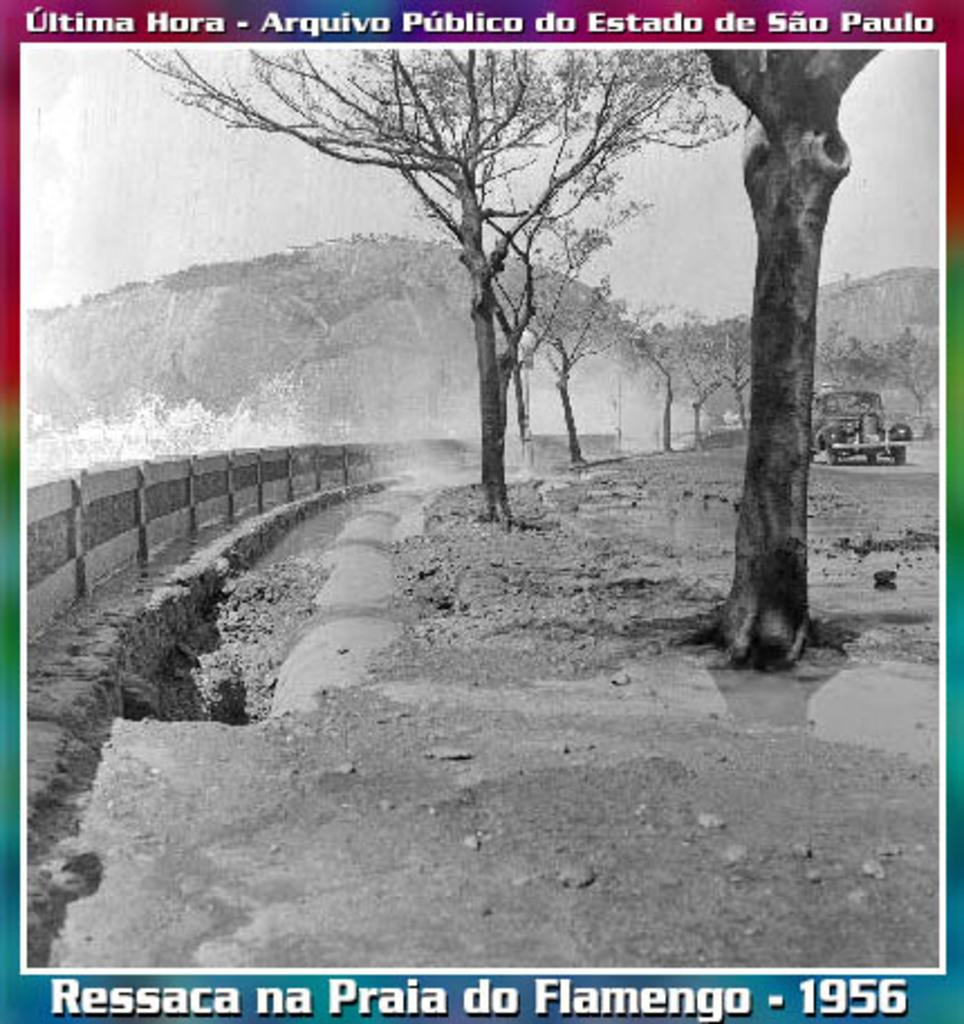What is featured on the poster in the image? The poster depicts a car parked on the road. What can be seen in the background of the poster? There are trees and hills visible in the background. How would you describe the road in the poster? The road is uneven. What direction is the car facing in the poster? The facts provided do not specify the direction the car is facing in the poster. Are there any bells visible in the image? There are no bells present in the image. 